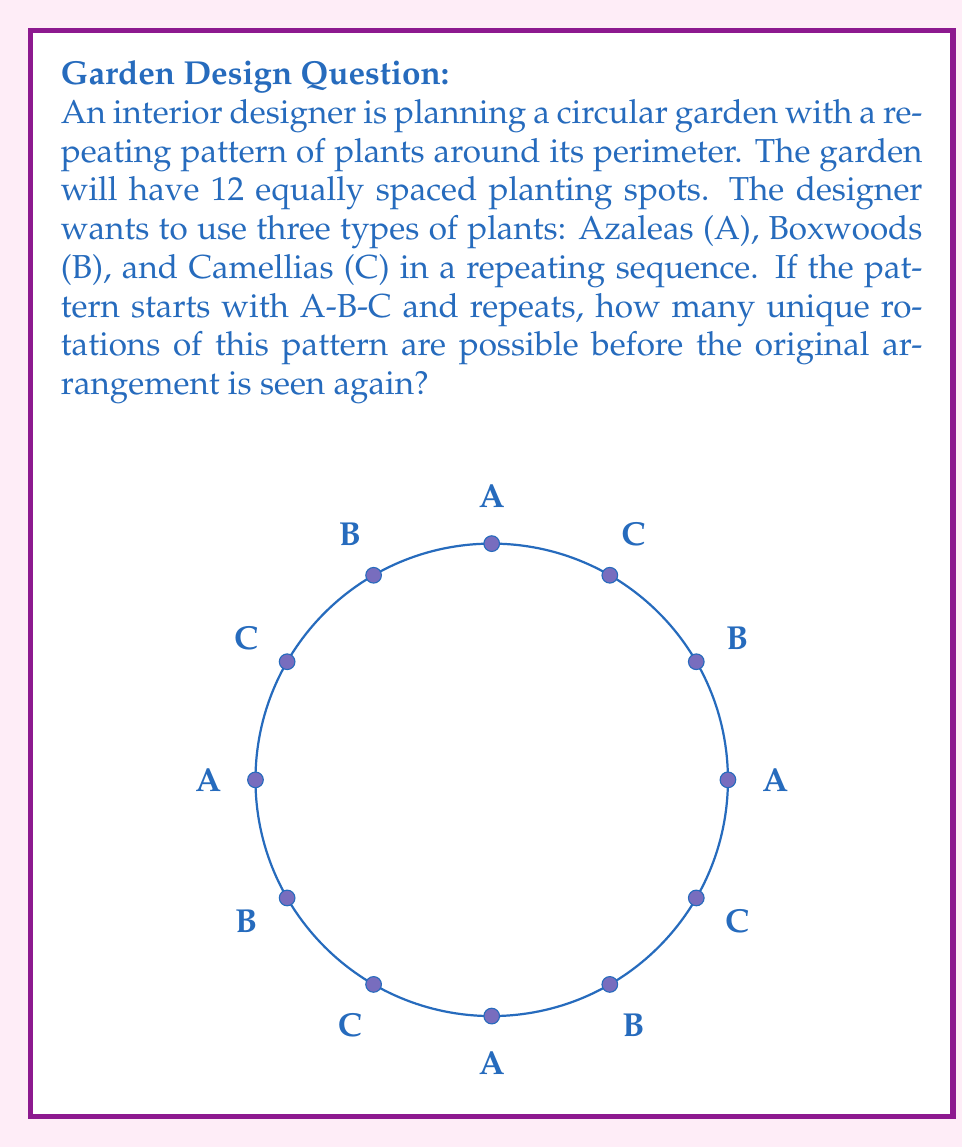Could you help me with this problem? Let's approach this step-by-step:

1) First, we need to understand that this problem is related to cyclic groups. The arrangement of plants forms a cyclic pattern that repeats around the garden.

2) The fundamental period of our pattern is A-B-C, which consists of 3 elements.

3) The total number of planting spots is 12.

4) To find the number of unique rotations, we need to calculate how many times we need to rotate the pattern before it returns to its original position. This is equivalent to finding the order of the cyclic group generated by the rotation.

5) Mathematically, this can be expressed as:

   $$\text{Number of unique rotations} = \frac{\text{Total number of elements}}{\text{Number of elements in the fundamental period}}$$

6) In this case:
   $$\text{Number of unique rotations} = \frac{12}{3} = 4$$

7) We can verify this:
   - Original: A-B-C-A-B-C-A-B-C-A-B-C
   - After 1 rotation: C-A-B-C-A-B-C-A-B-C-A-B
   - After 2 rotations: B-C-A-B-C-A-B-C-A-B-C-A
   - After 3 rotations: A-B-C-A-B-C-A-B-C-A-B-C (back to original)

8) This demonstrates that the cyclic group generated by the rotation has order 4.
Answer: 4 